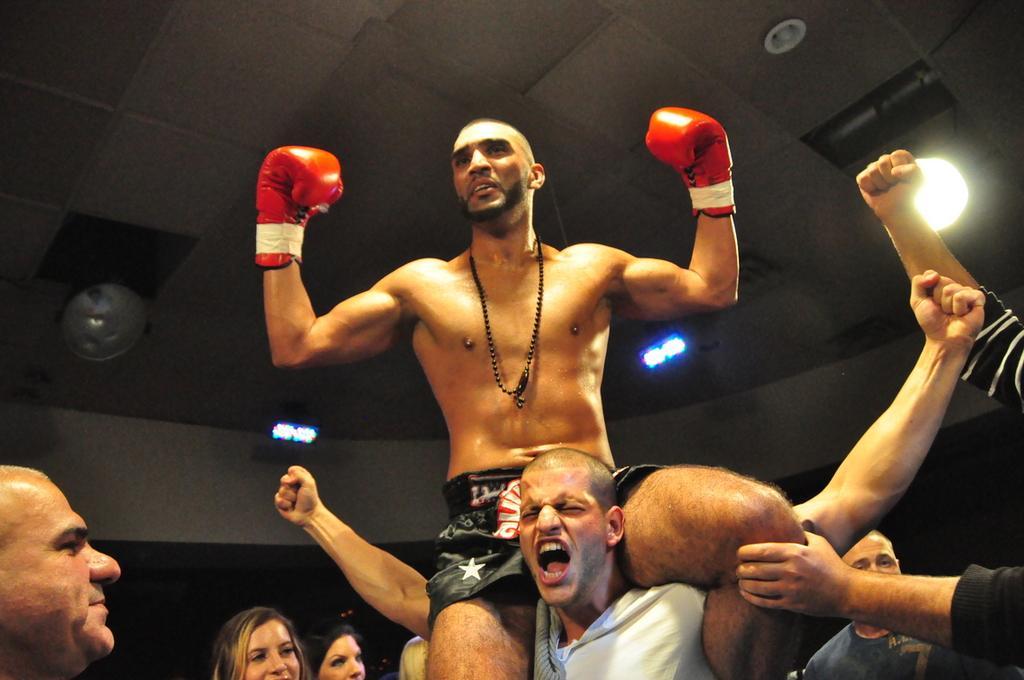Can you describe this image briefly? In this image, I can see a man standing and carrying another man. I can see the ceiling lights, which are attached to the ceiling. On the right side of the image, I can see a person's hands. At the bottom of the image, I can see a group of people. 